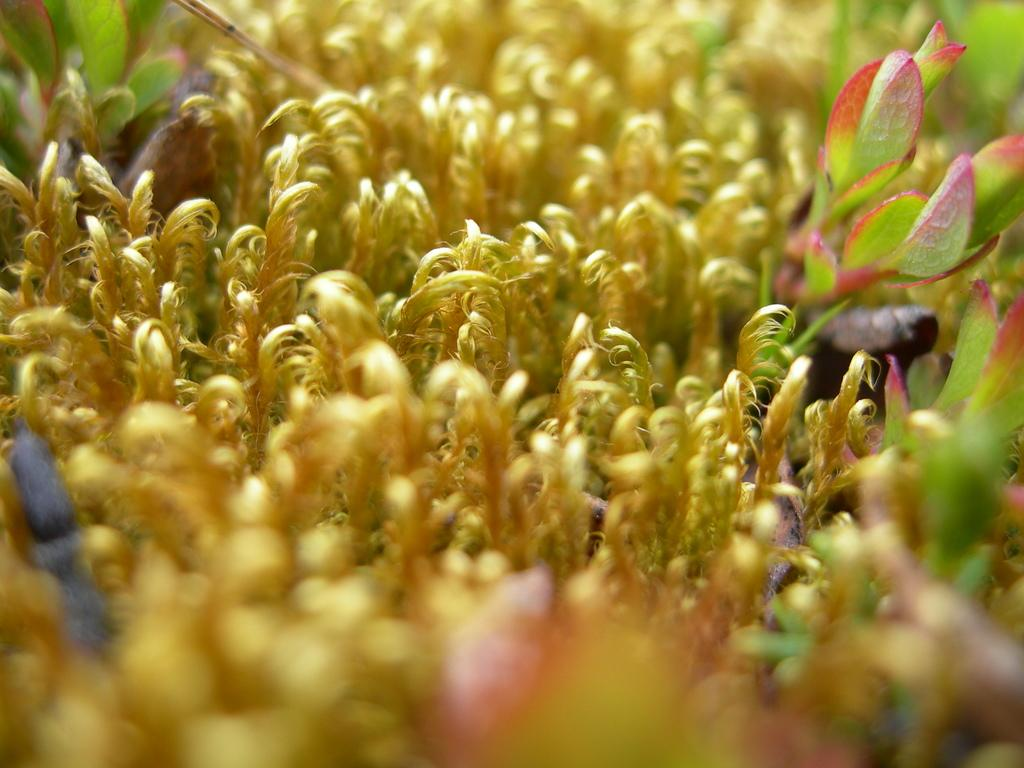What type of living organisms can be seen in the image? Plants can be seen in the image. What color is the feather that is hanging from the plant in the image? There is no feather present in the image; it only contains plants. 